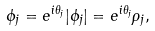<formula> <loc_0><loc_0><loc_500><loc_500>\phi _ { j } = e ^ { i \theta _ { j } } | \phi _ { j } | = e ^ { i \theta _ { j } } \rho _ { j } ,</formula> 